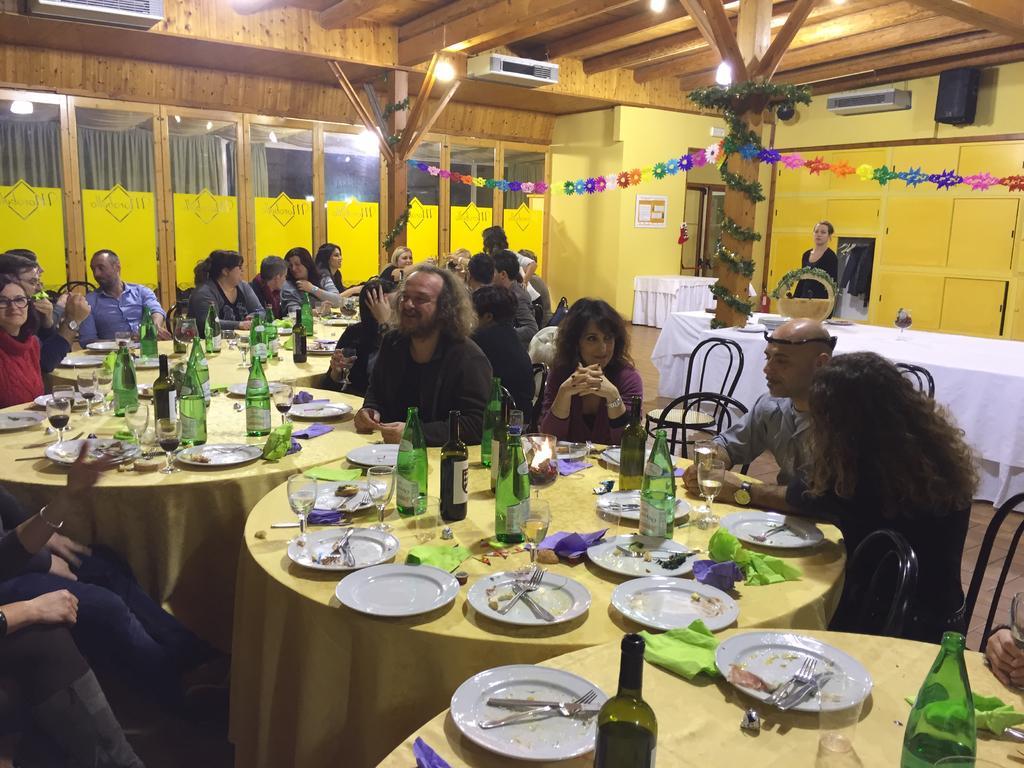Could you give a brief overview of what you see in this image? This is a picture of restaurant. here we can see few persons sitting on chairs infront of a table and on the table we can see bottles,glasses, plates and a food init,spoons and forks. We can see one woman standing here. This is a decorative paper. These are window glasses. This is an AC. These are lights. 